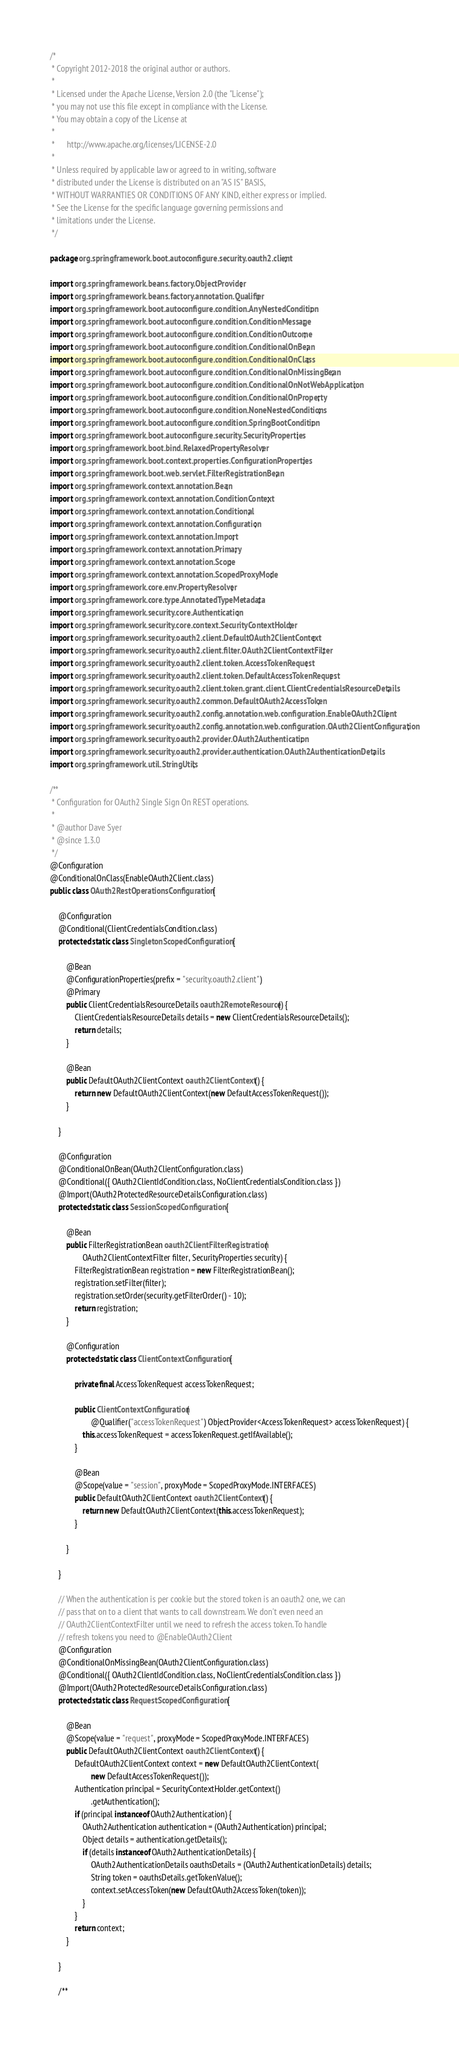Convert code to text. <code><loc_0><loc_0><loc_500><loc_500><_Java_>/*
 * Copyright 2012-2018 the original author or authors.
 *
 * Licensed under the Apache License, Version 2.0 (the "License");
 * you may not use this file except in compliance with the License.
 * You may obtain a copy of the License at
 *
 *      http://www.apache.org/licenses/LICENSE-2.0
 *
 * Unless required by applicable law or agreed to in writing, software
 * distributed under the License is distributed on an "AS IS" BASIS,
 * WITHOUT WARRANTIES OR CONDITIONS OF ANY KIND, either express or implied.
 * See the License for the specific language governing permissions and
 * limitations under the License.
 */

package org.springframework.boot.autoconfigure.security.oauth2.client;

import org.springframework.beans.factory.ObjectProvider;
import org.springframework.beans.factory.annotation.Qualifier;
import org.springframework.boot.autoconfigure.condition.AnyNestedCondition;
import org.springframework.boot.autoconfigure.condition.ConditionMessage;
import org.springframework.boot.autoconfigure.condition.ConditionOutcome;
import org.springframework.boot.autoconfigure.condition.ConditionalOnBean;
import org.springframework.boot.autoconfigure.condition.ConditionalOnClass;
import org.springframework.boot.autoconfigure.condition.ConditionalOnMissingBean;
import org.springframework.boot.autoconfigure.condition.ConditionalOnNotWebApplication;
import org.springframework.boot.autoconfigure.condition.ConditionalOnProperty;
import org.springframework.boot.autoconfigure.condition.NoneNestedConditions;
import org.springframework.boot.autoconfigure.condition.SpringBootCondition;
import org.springframework.boot.autoconfigure.security.SecurityProperties;
import org.springframework.boot.bind.RelaxedPropertyResolver;
import org.springframework.boot.context.properties.ConfigurationProperties;
import org.springframework.boot.web.servlet.FilterRegistrationBean;
import org.springframework.context.annotation.Bean;
import org.springframework.context.annotation.ConditionContext;
import org.springframework.context.annotation.Conditional;
import org.springframework.context.annotation.Configuration;
import org.springframework.context.annotation.Import;
import org.springframework.context.annotation.Primary;
import org.springframework.context.annotation.Scope;
import org.springframework.context.annotation.ScopedProxyMode;
import org.springframework.core.env.PropertyResolver;
import org.springframework.core.type.AnnotatedTypeMetadata;
import org.springframework.security.core.Authentication;
import org.springframework.security.core.context.SecurityContextHolder;
import org.springframework.security.oauth2.client.DefaultOAuth2ClientContext;
import org.springframework.security.oauth2.client.filter.OAuth2ClientContextFilter;
import org.springframework.security.oauth2.client.token.AccessTokenRequest;
import org.springframework.security.oauth2.client.token.DefaultAccessTokenRequest;
import org.springframework.security.oauth2.client.token.grant.client.ClientCredentialsResourceDetails;
import org.springframework.security.oauth2.common.DefaultOAuth2AccessToken;
import org.springframework.security.oauth2.config.annotation.web.configuration.EnableOAuth2Client;
import org.springframework.security.oauth2.config.annotation.web.configuration.OAuth2ClientConfiguration;
import org.springframework.security.oauth2.provider.OAuth2Authentication;
import org.springframework.security.oauth2.provider.authentication.OAuth2AuthenticationDetails;
import org.springframework.util.StringUtils;

/**
 * Configuration for OAuth2 Single Sign On REST operations.
 *
 * @author Dave Syer
 * @since 1.3.0
 */
@Configuration
@ConditionalOnClass(EnableOAuth2Client.class)
public class OAuth2RestOperationsConfiguration {

	@Configuration
	@Conditional(ClientCredentialsCondition.class)
	protected static class SingletonScopedConfiguration {

		@Bean
		@ConfigurationProperties(prefix = "security.oauth2.client")
		@Primary
		public ClientCredentialsResourceDetails oauth2RemoteResource() {
			ClientCredentialsResourceDetails details = new ClientCredentialsResourceDetails();
			return details;
		}

		@Bean
		public DefaultOAuth2ClientContext oauth2ClientContext() {
			return new DefaultOAuth2ClientContext(new DefaultAccessTokenRequest());
		}

	}

	@Configuration
	@ConditionalOnBean(OAuth2ClientConfiguration.class)
	@Conditional({ OAuth2ClientIdCondition.class, NoClientCredentialsCondition.class })
	@Import(OAuth2ProtectedResourceDetailsConfiguration.class)
	protected static class SessionScopedConfiguration {

		@Bean
		public FilterRegistrationBean oauth2ClientFilterRegistration(
				OAuth2ClientContextFilter filter, SecurityProperties security) {
			FilterRegistrationBean registration = new FilterRegistrationBean();
			registration.setFilter(filter);
			registration.setOrder(security.getFilterOrder() - 10);
			return registration;
		}

		@Configuration
		protected static class ClientContextConfiguration {

			private final AccessTokenRequest accessTokenRequest;

			public ClientContextConfiguration(
					@Qualifier("accessTokenRequest") ObjectProvider<AccessTokenRequest> accessTokenRequest) {
				this.accessTokenRequest = accessTokenRequest.getIfAvailable();
			}

			@Bean
			@Scope(value = "session", proxyMode = ScopedProxyMode.INTERFACES)
			public DefaultOAuth2ClientContext oauth2ClientContext() {
				return new DefaultOAuth2ClientContext(this.accessTokenRequest);
			}

		}

	}

	// When the authentication is per cookie but the stored token is an oauth2 one, we can
	// pass that on to a client that wants to call downstream. We don't even need an
	// OAuth2ClientContextFilter until we need to refresh the access token. To handle
	// refresh tokens you need to @EnableOAuth2Client
	@Configuration
	@ConditionalOnMissingBean(OAuth2ClientConfiguration.class)
	@Conditional({ OAuth2ClientIdCondition.class, NoClientCredentialsCondition.class })
	@Import(OAuth2ProtectedResourceDetailsConfiguration.class)
	protected static class RequestScopedConfiguration {

		@Bean
		@Scope(value = "request", proxyMode = ScopedProxyMode.INTERFACES)
		public DefaultOAuth2ClientContext oauth2ClientContext() {
			DefaultOAuth2ClientContext context = new DefaultOAuth2ClientContext(
					new DefaultAccessTokenRequest());
			Authentication principal = SecurityContextHolder.getContext()
					.getAuthentication();
			if (principal instanceof OAuth2Authentication) {
				OAuth2Authentication authentication = (OAuth2Authentication) principal;
				Object details = authentication.getDetails();
				if (details instanceof OAuth2AuthenticationDetails) {
					OAuth2AuthenticationDetails oauthsDetails = (OAuth2AuthenticationDetails) details;
					String token = oauthsDetails.getTokenValue();
					context.setAccessToken(new DefaultOAuth2AccessToken(token));
				}
			}
			return context;
		}

	}

	/**</code> 